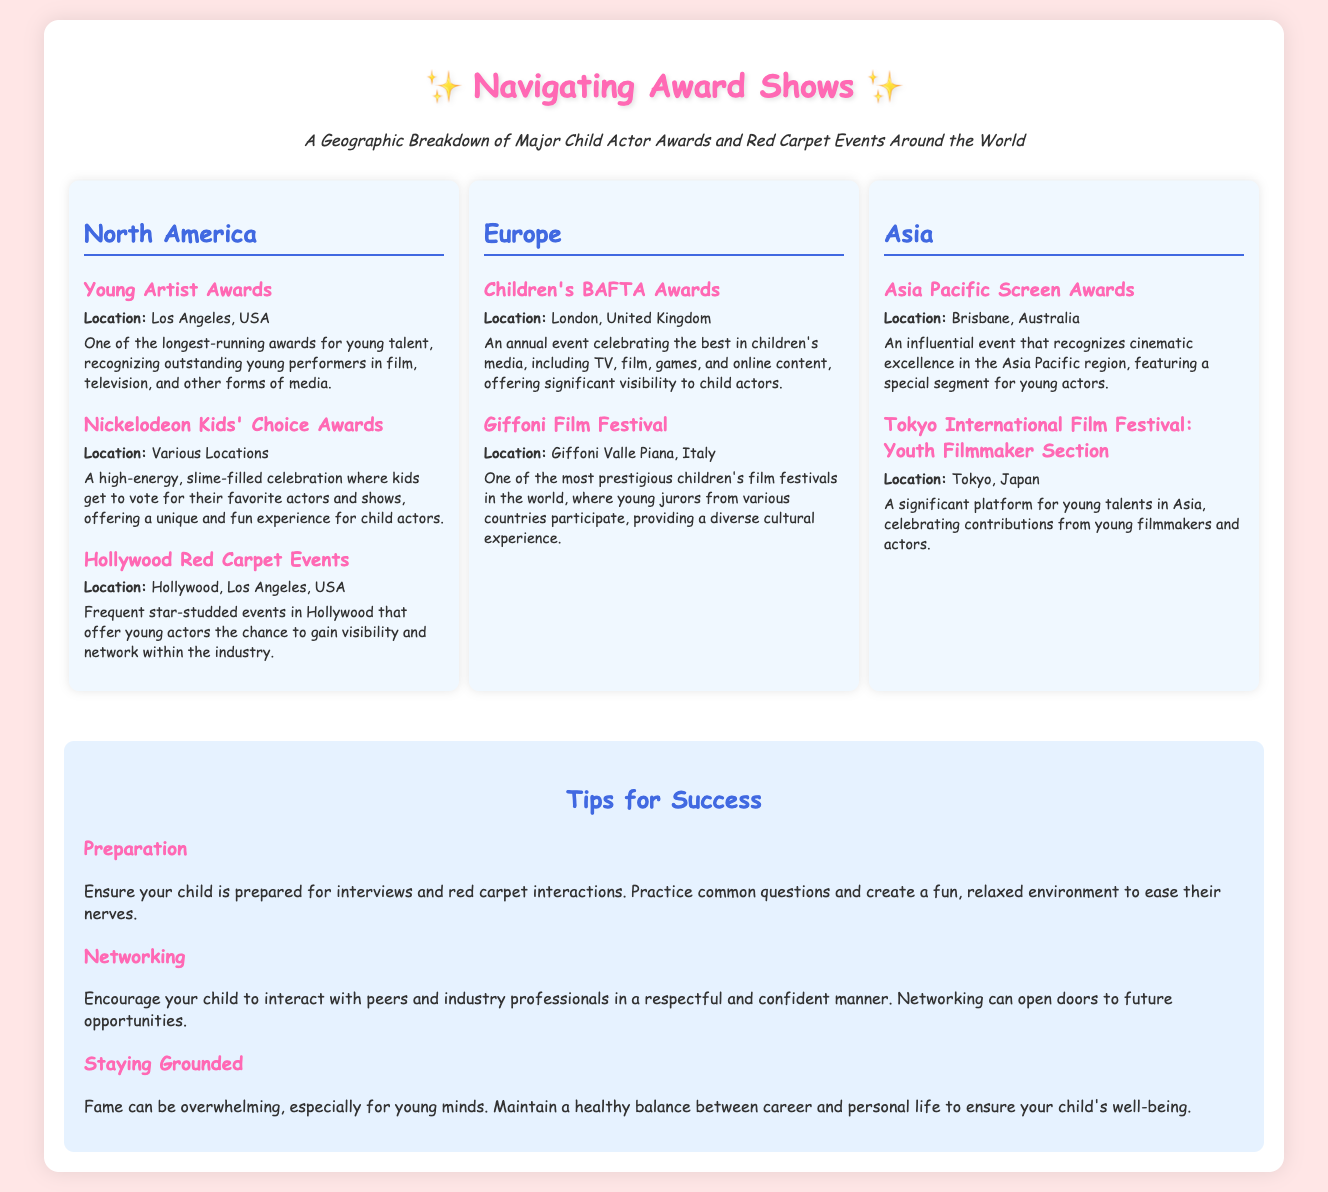What is the location of the Young Artist Awards? The location for the Young Artist Awards is mentioned as Los Angeles, USA.
Answer: Los Angeles, USA How many events are listed under the North America region? The North America region includes three events as shown in the infographic.
Answer: 3 What annual event is celebrated for children’s media in Europe? The annual event in Europe that celebrates children's media is called the Children's BAFTA Awards.
Answer: Children's BAFTA Awards Which festival in Asia focuses on young filmmakers? The Tokyo International Film Festival: Youth Filmmaker Section specifically focuses on young filmmakers in Asia.
Answer: Tokyo International Film Festival: Youth Filmmaker Section What is a major tip for success mentioned in the infographic? One major tip mentioned for success is "Preparation," which highlights the importance of being prepared for interactions.
Answer: Preparation How does the Giffoni Film Festival distinguish itself? The Giffoni Film Festival is distinguished by the participation of young jurors from various countries, offering a diverse cultural experience.
Answer: Young jurors from various countries Which event allows children to vote for their favorite actors? The Nickelodeon Kids' Choice Awards allows children to vote for their favorite actors and shows.
Answer: Nickelodeon Kids' Choice Awards What geographic regions are covered in the infographic? The infographic covers the regions of North America, Europe, and Asia as specified.
Answer: North America, Europe, Asia 